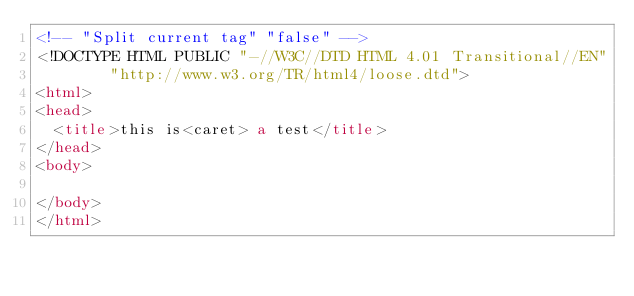Convert code to text. <code><loc_0><loc_0><loc_500><loc_500><_HTML_><!-- "Split current tag" "false" -->
<!DOCTYPE HTML PUBLIC "-//W3C//DTD HTML 4.01 Transitional//EN"
        "http://www.w3.org/TR/html4/loose.dtd">
<html>
<head>
  <title>this is<caret> a test</title>
</head>
<body>

</body>
</html></code> 